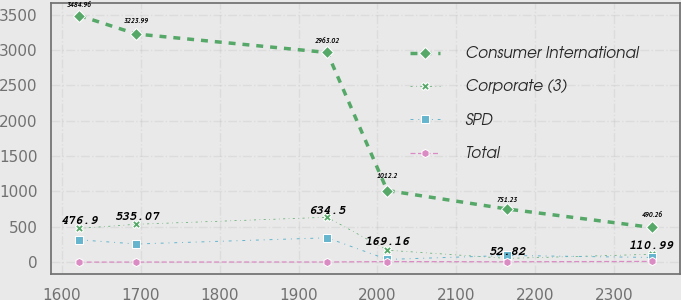Convert chart to OTSL. <chart><loc_0><loc_0><loc_500><loc_500><line_chart><ecel><fcel>Consumer International<fcel>Corporate (3)<fcel>SPD<fcel>Total<nl><fcel>1622.04<fcel>3484.96<fcel>476.9<fcel>315.71<fcel>0<nl><fcel>1694.6<fcel>3223.99<fcel>535.07<fcel>256.67<fcel>1<nl><fcel>1936.31<fcel>2963.02<fcel>634.5<fcel>343.88<fcel>2<nl><fcel>2012.31<fcel>1012.2<fcel>169.16<fcel>38.09<fcel>7.74<nl><fcel>2164.21<fcel>751.23<fcel>52.82<fcel>94.41<fcel>4.84<nl><fcel>2347.64<fcel>490.26<fcel>110.99<fcel>66.25<fcel>10.04<nl></chart> 